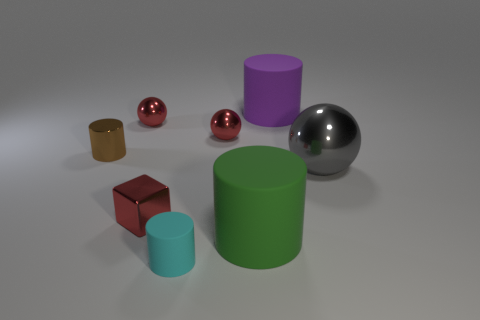Subtract all matte cylinders. How many cylinders are left? 1 Add 1 big rubber objects. How many objects exist? 9 Subtract all yellow cylinders. Subtract all purple balls. How many cylinders are left? 4 Subtract all spheres. How many objects are left? 5 Subtract all big green objects. Subtract all tiny cyan matte things. How many objects are left? 6 Add 8 purple cylinders. How many purple cylinders are left? 9 Add 8 blue matte cubes. How many blue matte cubes exist? 8 Subtract 0 brown cubes. How many objects are left? 8 